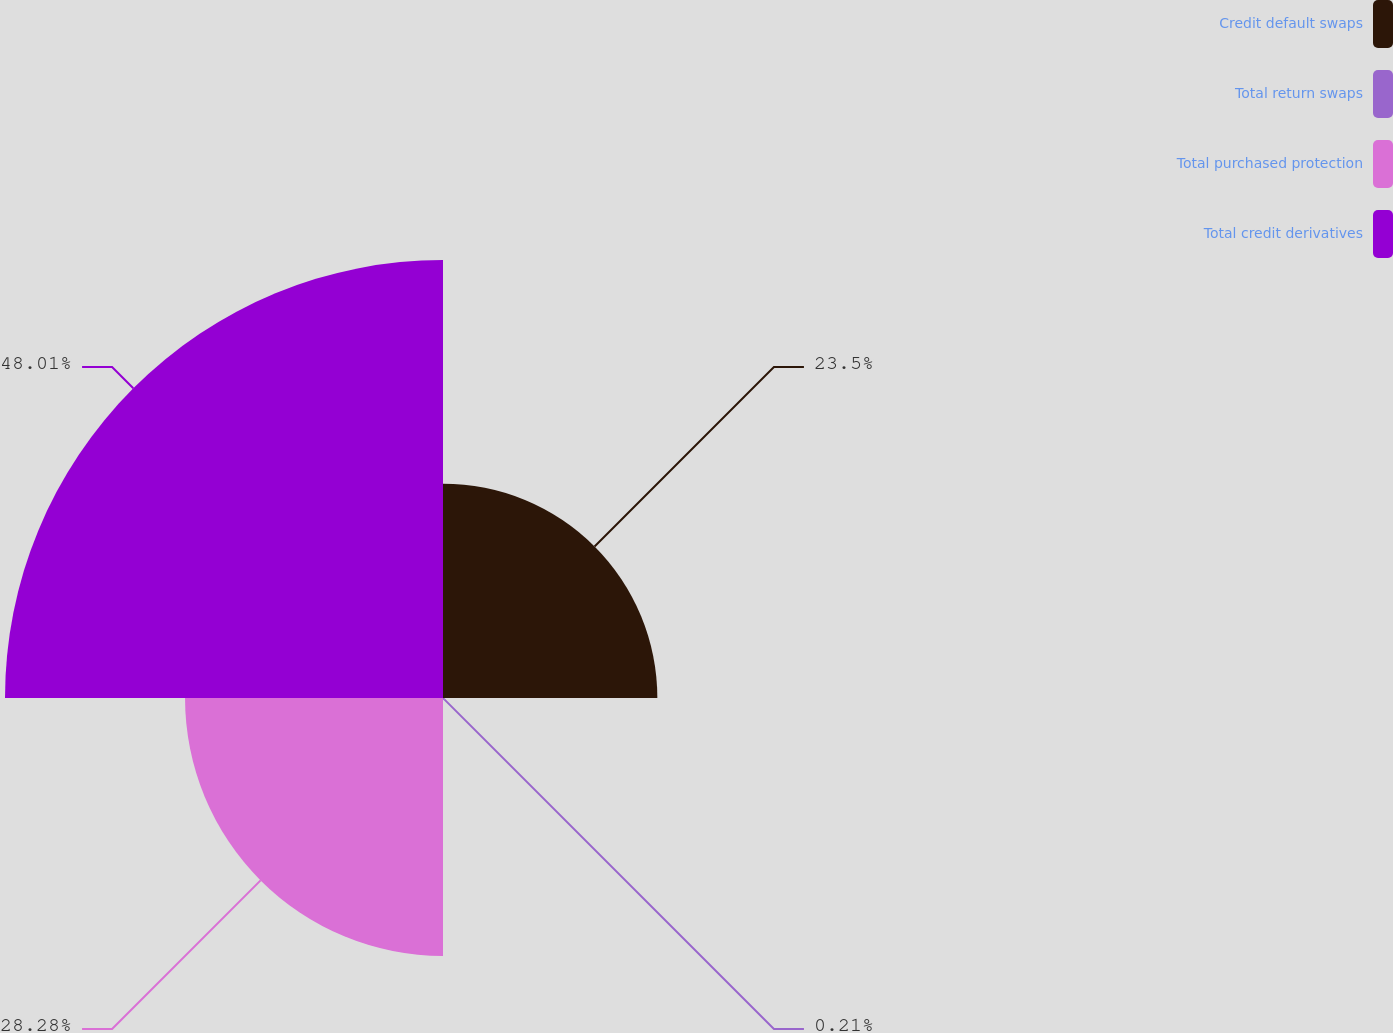<chart> <loc_0><loc_0><loc_500><loc_500><pie_chart><fcel>Credit default swaps<fcel>Total return swaps<fcel>Total purchased protection<fcel>Total credit derivatives<nl><fcel>23.5%<fcel>0.21%<fcel>28.28%<fcel>48.02%<nl></chart> 